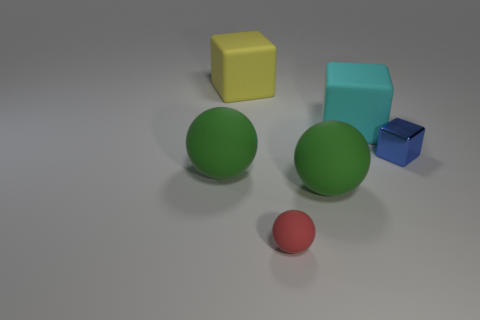Are there any other things that have the same material as the blue thing?
Ensure brevity in your answer.  No. Is there a small matte thing of the same shape as the large cyan object?
Your response must be concise. No. What shape is the cyan object right of the big block left of the cyan matte block?
Make the answer very short. Cube. What number of other tiny red spheres have the same material as the small ball?
Make the answer very short. 0. There is another large cube that is made of the same material as the big cyan block; what color is it?
Your answer should be compact. Yellow. There is a green object in front of the large green rubber sphere on the left side of the big rubber sphere to the right of the yellow cube; what size is it?
Give a very brief answer. Large. Are there fewer cyan matte blocks than small cyan shiny cylinders?
Ensure brevity in your answer.  No. The other large rubber object that is the same shape as the big cyan object is what color?
Give a very brief answer. Yellow. Are there any large green matte spheres behind the large green object that is right of the small thing in front of the tiny blue block?
Offer a terse response. Yes. Do the shiny thing and the big cyan matte thing have the same shape?
Your response must be concise. Yes. 